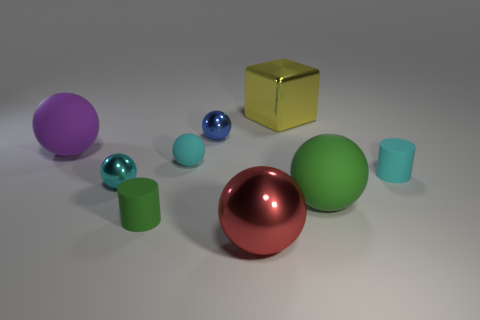There is a large metallic cube on the right side of the red thing; are there any tiny cyan matte cylinders that are on the left side of it?
Your answer should be very brief. No. What color is the big thing that is on the right side of the red metallic sphere and in front of the yellow metallic thing?
Ensure brevity in your answer.  Green. The metallic cube is what size?
Offer a very short reply. Large. How many other balls have the same size as the blue metal sphere?
Offer a very short reply. 2. Is the small thing that is to the right of the red sphere made of the same material as the large object that is behind the purple matte thing?
Your answer should be very brief. No. What material is the ball right of the large metallic object in front of the large yellow thing?
Keep it short and to the point. Rubber. There is a green object that is left of the red object; what is its material?
Make the answer very short. Rubber. What number of other big purple matte things are the same shape as the purple object?
Provide a succinct answer. 0. What material is the large object that is behind the small metal sphere behind the small cyan rubber object on the right side of the metal block made of?
Provide a succinct answer. Metal. There is a yellow block; are there any cyan metallic things behind it?
Ensure brevity in your answer.  No. 